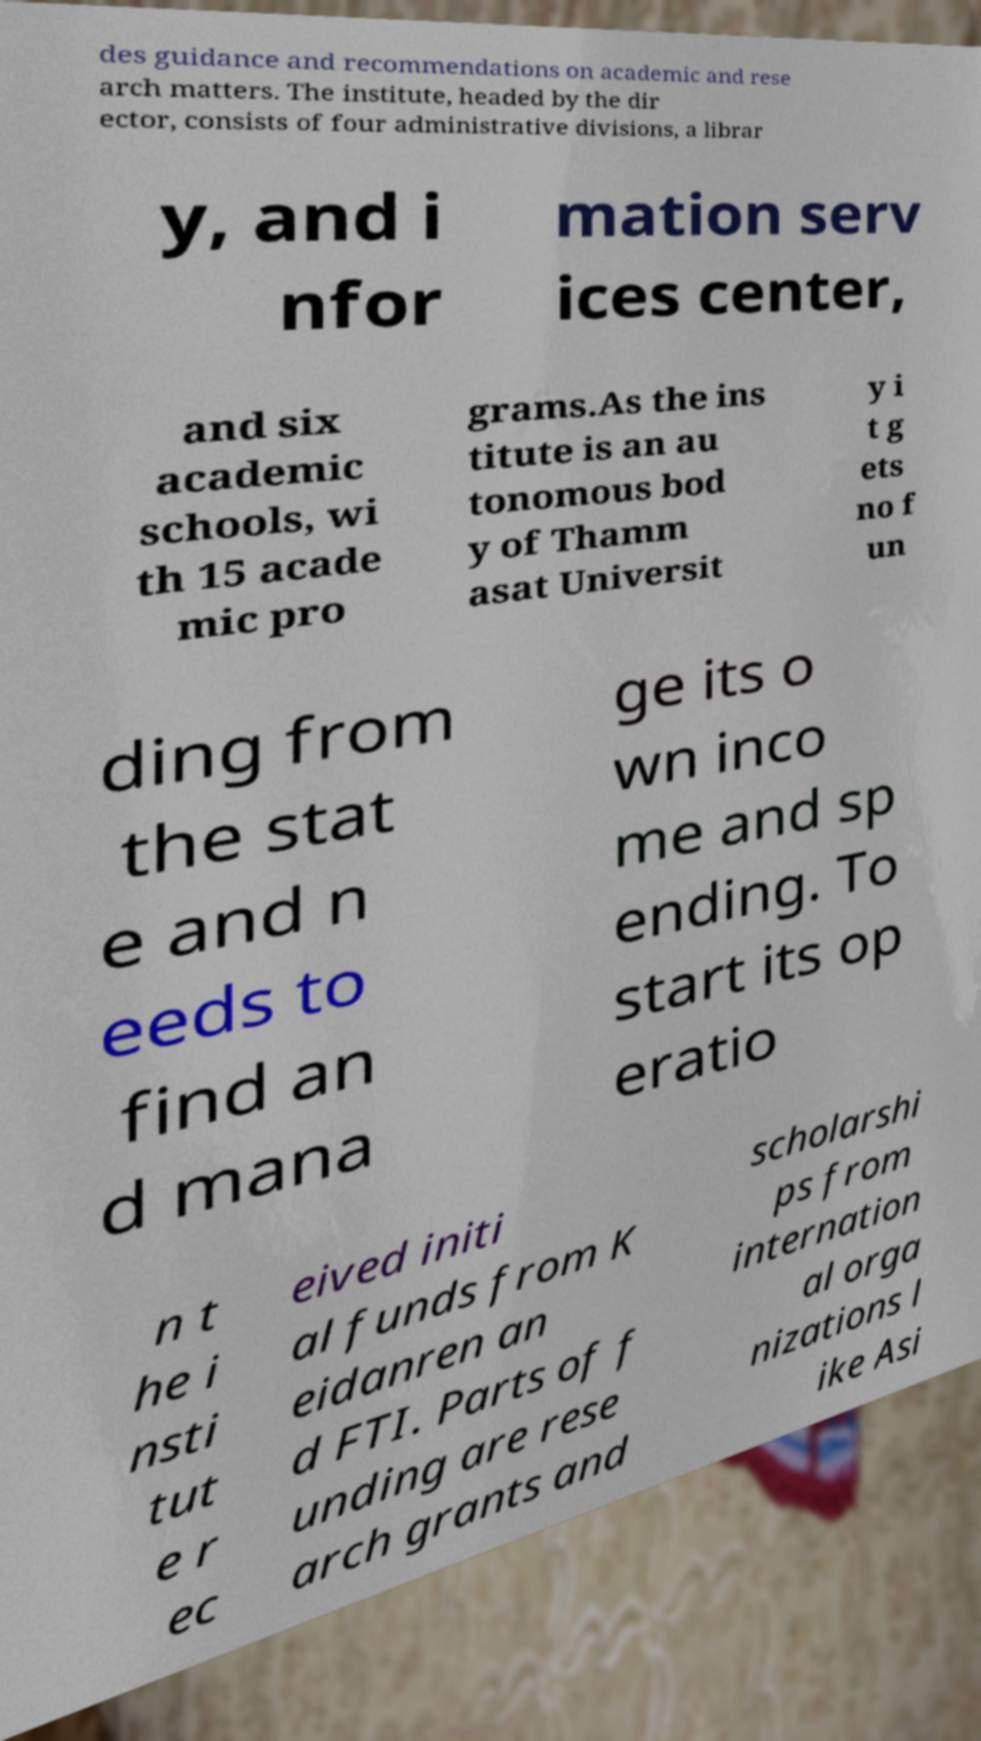Could you extract and type out the text from this image? des guidance and recommendations on academic and rese arch matters. The institute, headed by the dir ector, consists of four administrative divisions, a librar y, and i nfor mation serv ices center, and six academic schools, wi th 15 acade mic pro grams.As the ins titute is an au tonomous bod y of Thamm asat Universit y i t g ets no f un ding from the stat e and n eeds to find an d mana ge its o wn inco me and sp ending. To start its op eratio n t he i nsti tut e r ec eived initi al funds from K eidanren an d FTI. Parts of f unding are rese arch grants and scholarshi ps from internation al orga nizations l ike Asi 